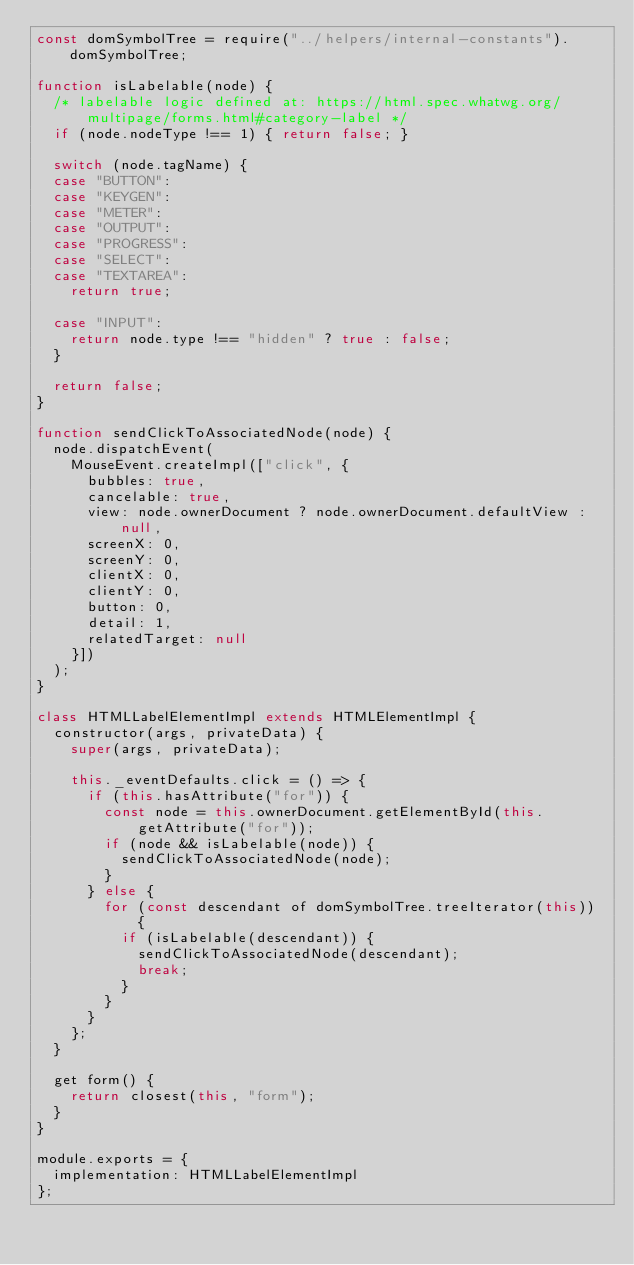<code> <loc_0><loc_0><loc_500><loc_500><_JavaScript_>const domSymbolTree = require("../helpers/internal-constants").domSymbolTree;

function isLabelable(node) {
  /* labelable logic defined at: https://html.spec.whatwg.org/multipage/forms.html#category-label */
  if (node.nodeType !== 1) { return false; }

  switch (node.tagName) {
  case "BUTTON":
  case "KEYGEN":
  case "METER":
  case "OUTPUT":
  case "PROGRESS":
  case "SELECT":
  case "TEXTAREA":
    return true;

  case "INPUT":
    return node.type !== "hidden" ? true : false;
  }

  return false;
}

function sendClickToAssociatedNode(node) {
  node.dispatchEvent(
    MouseEvent.createImpl(["click", {
      bubbles: true,
      cancelable: true,
      view: node.ownerDocument ? node.ownerDocument.defaultView : null,
      screenX: 0,
      screenY: 0,
      clientX: 0,
      clientY: 0,
      button: 0,
      detail: 1,
      relatedTarget: null
    }])
  );
}

class HTMLLabelElementImpl extends HTMLElementImpl {
  constructor(args, privateData) {
    super(args, privateData);

    this._eventDefaults.click = () => {
      if (this.hasAttribute("for")) {
        const node = this.ownerDocument.getElementById(this.getAttribute("for"));
        if (node && isLabelable(node)) {
          sendClickToAssociatedNode(node);
        }
      } else {
        for (const descendant of domSymbolTree.treeIterator(this)) {
          if (isLabelable(descendant)) {
            sendClickToAssociatedNode(descendant);
            break;
          }
        }
      }
    };
  }

  get form() {
    return closest(this, "form");
  }
}

module.exports = {
  implementation: HTMLLabelElementImpl
};
</code> 